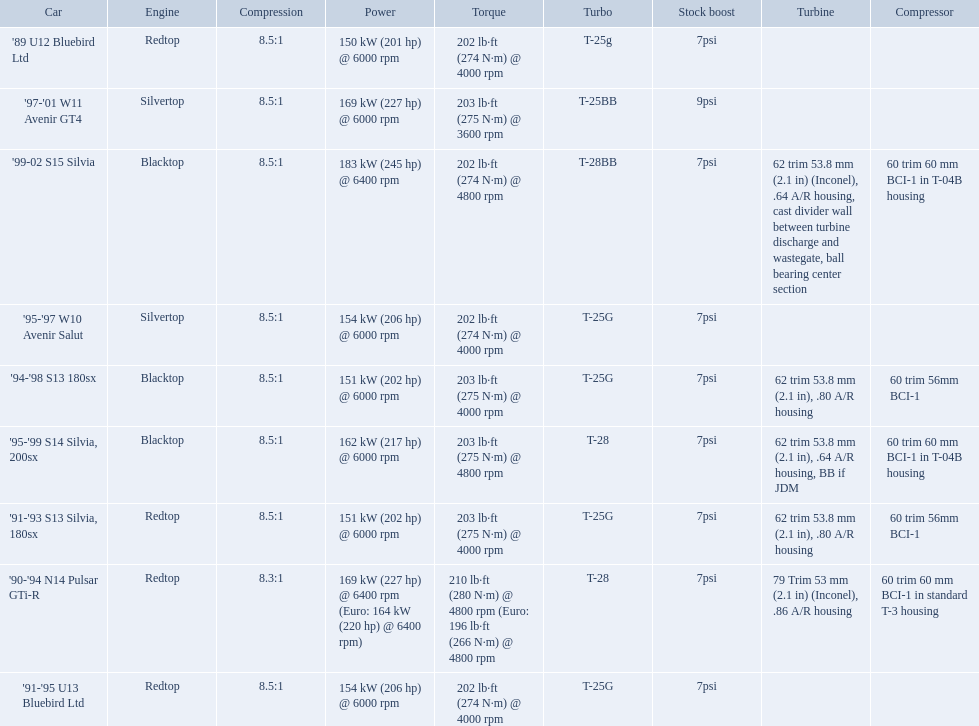Which cars list turbine details? '90-'94 N14 Pulsar GTi-R, '91-'93 S13 Silvia, 180sx, '94-'98 S13 180sx, '95-'99 S14 Silvia, 200sx, '99-02 S15 Silvia. Which of these hit their peak hp at the highest rpm? '90-'94 N14 Pulsar GTi-R, '99-02 S15 Silvia. Of those what is the compression of the only engine that isn't blacktop?? 8.3:1. Which of the cars uses the redtop engine? '89 U12 Bluebird Ltd, '91-'95 U13 Bluebird Ltd, '90-'94 N14 Pulsar GTi-R, '91-'93 S13 Silvia, 180sx. Of these, has more than 220 horsepower? '90-'94 N14 Pulsar GTi-R. What is the compression ratio of this car? 8.3:1. 